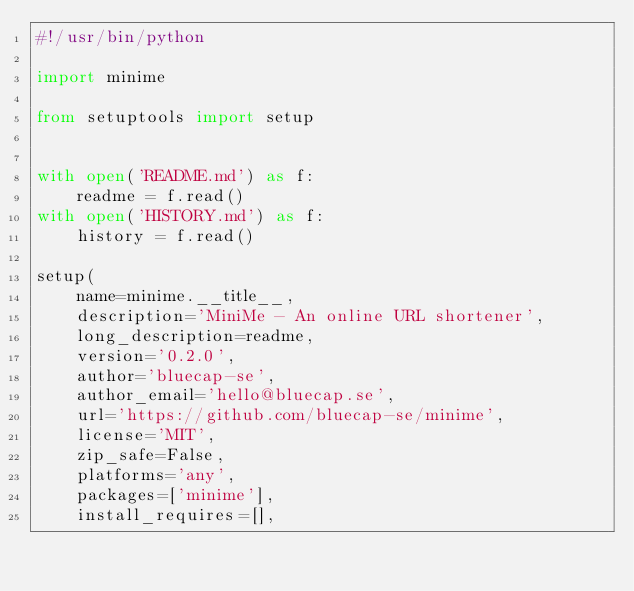Convert code to text. <code><loc_0><loc_0><loc_500><loc_500><_Python_>#!/usr/bin/python

import minime

from setuptools import setup


with open('README.md') as f:
    readme = f.read()
with open('HISTORY.md') as f:
    history = f.read()

setup(
    name=minime.__title__,
    description='MiniMe - An online URL shortener',
    long_description=readme,
    version='0.2.0',
    author='bluecap-se',
    author_email='hello@bluecap.se',
    url='https://github.com/bluecap-se/minime',
    license='MIT',
    zip_safe=False,
    platforms='any',
    packages=['minime'],
    install_requires=[],</code> 